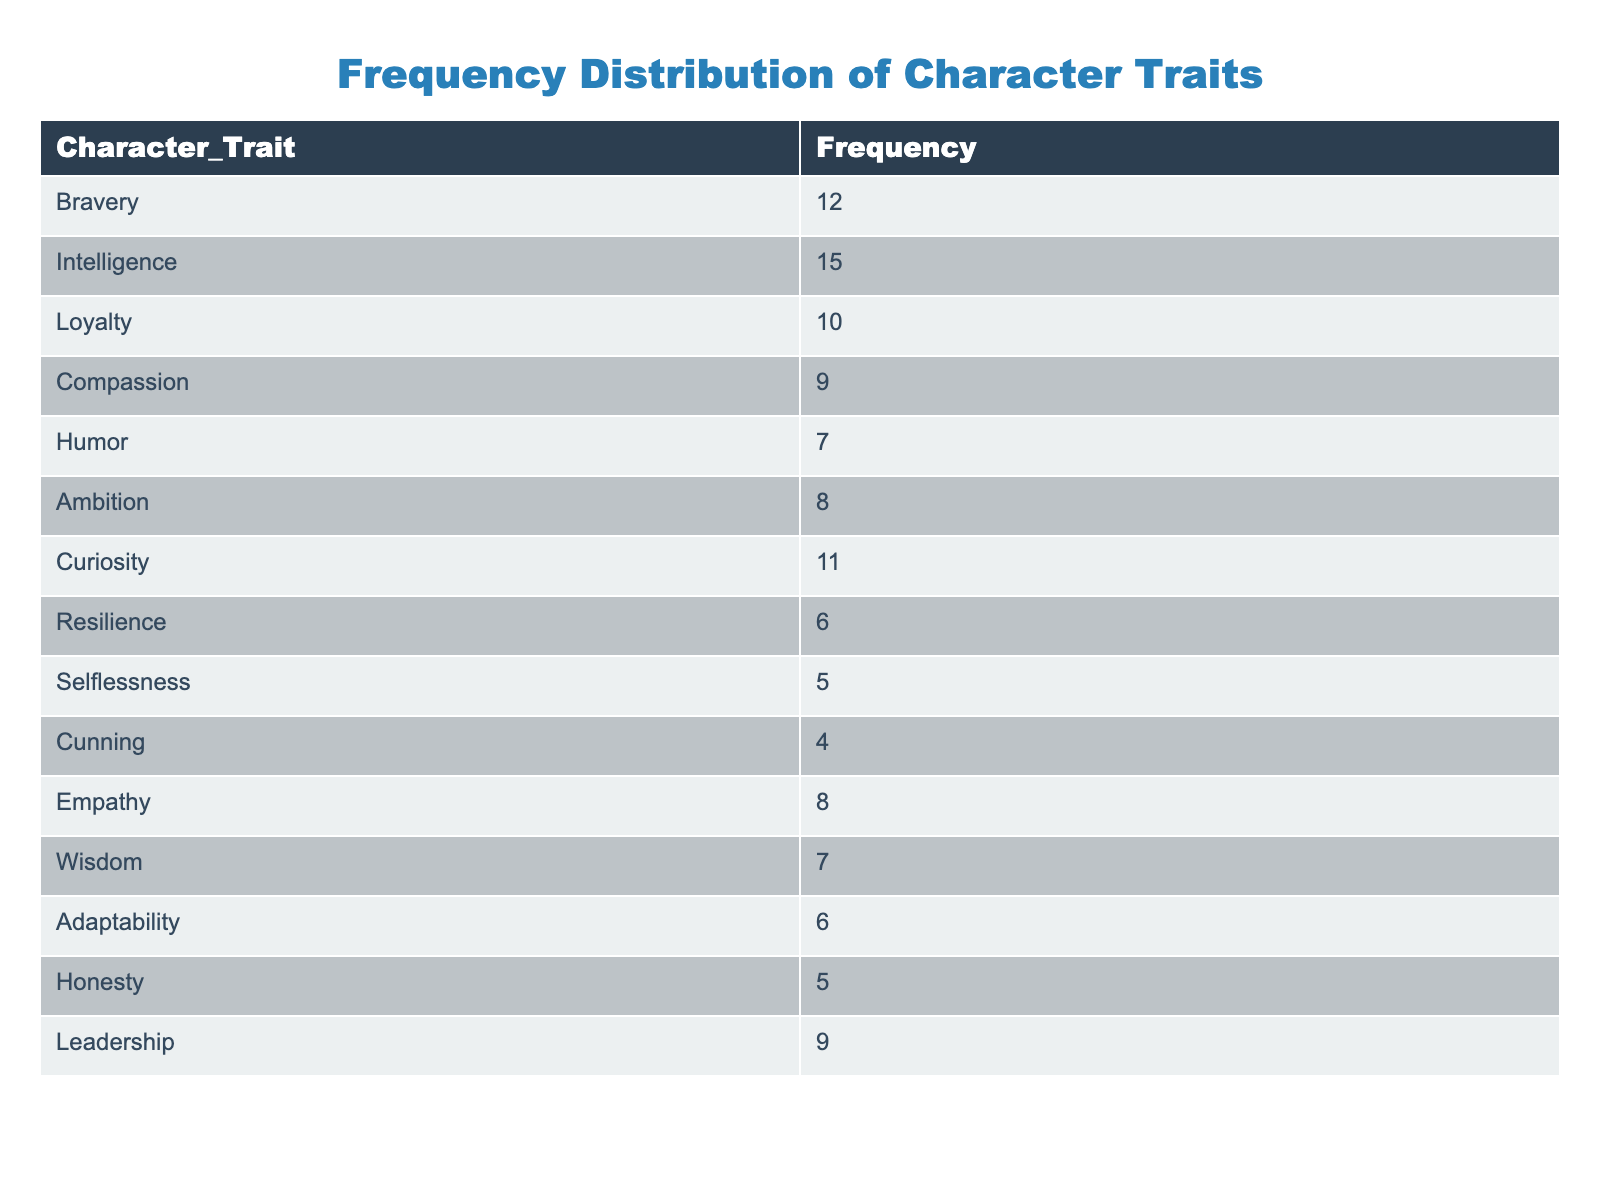What is the frequency of the character trait "Intelligence"? The frequency of the character trait "Intelligence" can be directly found in the table. It shows a value of 15.
Answer: 15 Which character trait has the lowest frequency? To determine the lowest frequency, I look through all the frequencies listed in the table. The frequencies range from 4 to 15, and "Cunning" has the lowest frequency at 4.
Answer: Cunning What is the sum of the frequencies of "Loyalty" and "Compassion"? First, I find the frequencies of both traits in the table: "Loyalty" is 10 and "Compassion" is 9. Then, I add them together: 10 + 9 = 19.
Answer: 19 Is "Resilience" more frequent than "Selflessness"? I check the frequencies in the table: "Resilience" has a frequency of 6, while "Selflessness" has a frequency of 5. Since 6 is greater than 5, the statement is true.
Answer: Yes What is the average frequency of all the character traits listed? I first sum all the frequencies: 12 + 15 + 10 + 9 + 7 + 8 + 11 + 6 + 5 + 4 + 8 + 7 + 6 + 5 + 9 =  114. There are 15 character traits, so I divide the total by 15: 114 / 15 = 7.6.
Answer: 7.6 How many character traits have a frequency greater than 10? I review the frequencies and count the traits: "Intelligence" (15), "Bravery" (12), and "Curiosity" (11) are the only traits with frequencies greater than 10. Thus, there are 3 traits.
Answer: 3 What is the difference in frequency between the character traits "Ambition" and "Humor"? I find the frequencies for both traits: "Ambition" is 8 and "Humor" is 7. I then calculate the difference: 8 - 7 = 1.
Answer: 1 Is the frequency of "Leadership" equal to the frequency of "Compassion"? I look at the frequencies: "Leadership" has a frequency of 9 and "Compassion" has a frequency of 9. Since both are equal, the answer is true.
Answer: Yes Which character trait has the second highest frequency? By examining the frequencies, I find that the highest frequency is 15 (Intelligence), and the second highest is 12 (Bravery).
Answer: Bravery 